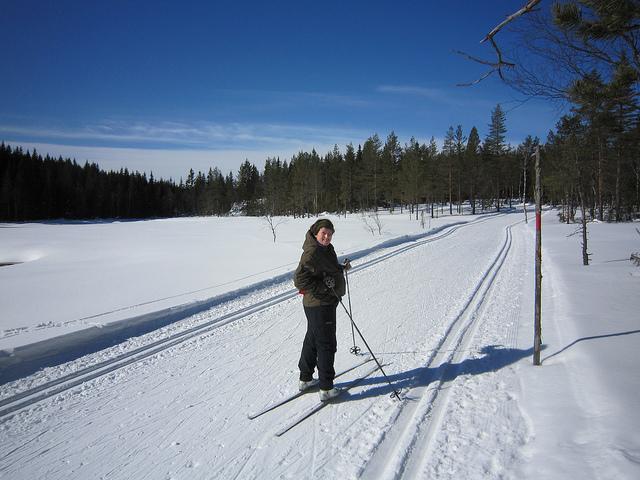How many ski tracks are visible?
Give a very brief answer. 2. How many lines are in the snow?
Give a very brief answer. 4. How many paths in the snow?
Give a very brief answer. 2. How many people are there?
Give a very brief answer. 1. How many giraffes are not drinking?
Give a very brief answer. 0. 